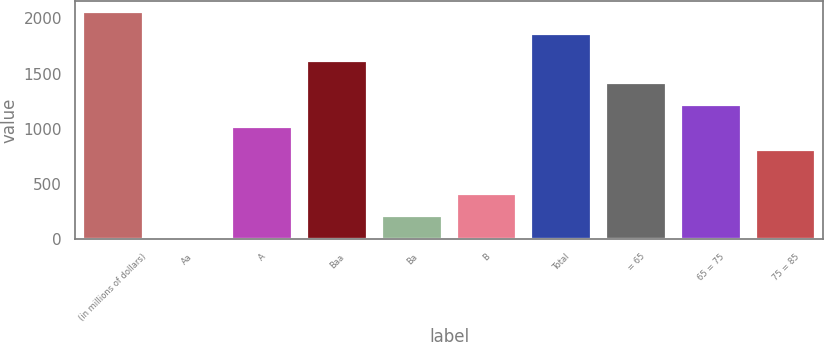Convert chart. <chart><loc_0><loc_0><loc_500><loc_500><bar_chart><fcel>(in millions of dollars)<fcel>Aa<fcel>A<fcel>Baa<fcel>Ba<fcel>B<fcel>Total<fcel>= 65<fcel>65 = 75<fcel>75 = 85<nl><fcel>2057.23<fcel>7.7<fcel>1010.85<fcel>1612.74<fcel>208.33<fcel>408.96<fcel>1856.6<fcel>1412.11<fcel>1211.48<fcel>810.22<nl></chart> 